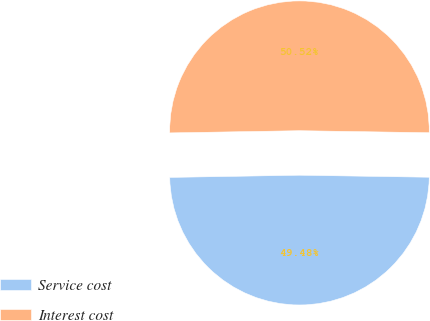Convert chart. <chart><loc_0><loc_0><loc_500><loc_500><pie_chart><fcel>Service cost<fcel>Interest cost<nl><fcel>49.48%<fcel>50.52%<nl></chart> 